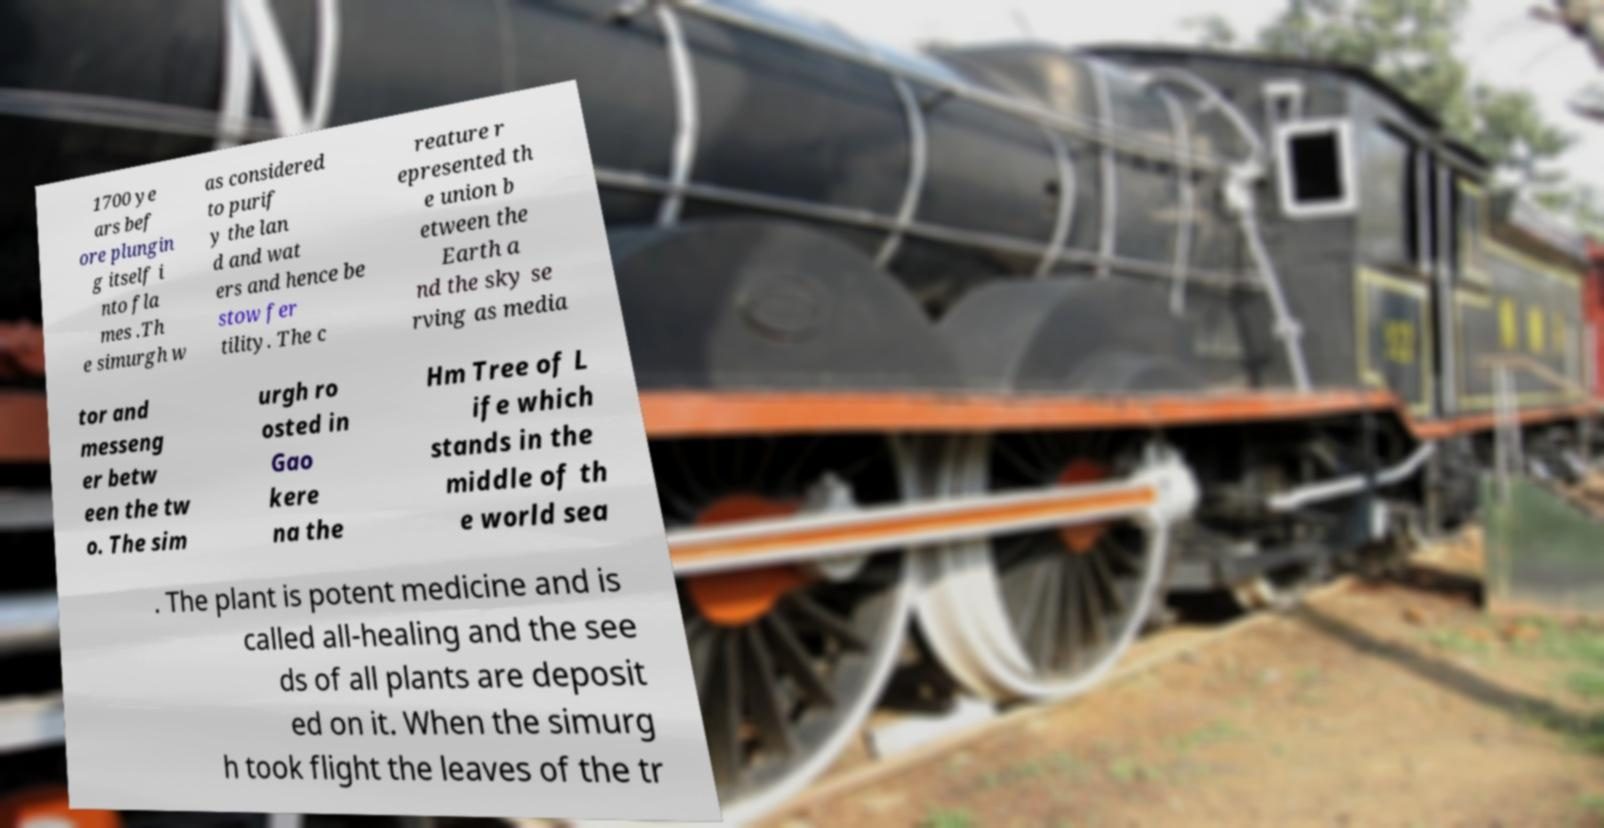I need the written content from this picture converted into text. Can you do that? 1700 ye ars bef ore plungin g itself i nto fla mes .Th e simurgh w as considered to purif y the lan d and wat ers and hence be stow fer tility. The c reature r epresented th e union b etween the Earth a nd the sky se rving as media tor and messeng er betw een the tw o. The sim urgh ro osted in Gao kere na the Hm Tree of L ife which stands in the middle of th e world sea . The plant is potent medicine and is called all-healing and the see ds of all plants are deposit ed on it. When the simurg h took flight the leaves of the tr 